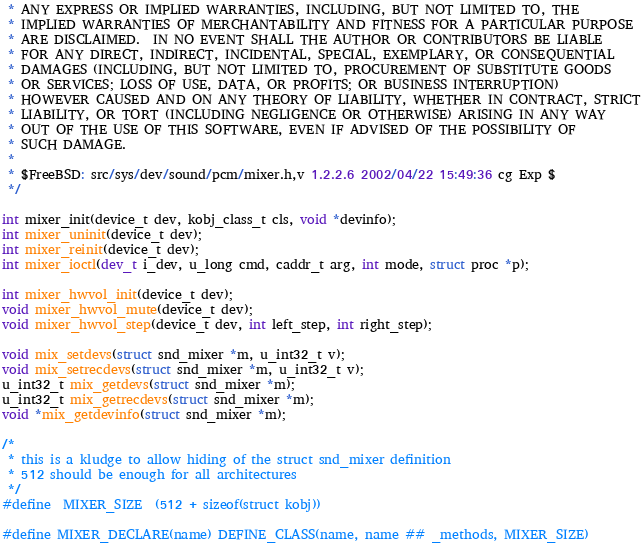<code> <loc_0><loc_0><loc_500><loc_500><_C_> * ANY EXPRESS OR IMPLIED WARRANTIES, INCLUDING, BUT NOT LIMITED TO, THE
 * IMPLIED WARRANTIES OF MERCHANTABILITY AND FITNESS FOR A PARTICULAR PURPOSE
 * ARE DISCLAIMED.  IN NO EVENT SHALL THE AUTHOR OR CONTRIBUTORS BE LIABLE
 * FOR ANY DIRECT, INDIRECT, INCIDENTAL, SPECIAL, EXEMPLARY, OR CONSEQUENTIAL
 * DAMAGES (INCLUDING, BUT NOT LIMITED TO, PROCUREMENT OF SUBSTITUTE GOODS
 * OR SERVICES; LOSS OF USE, DATA, OR PROFITS; OR BUSINESS INTERRUPTION)
 * HOWEVER CAUSED AND ON ANY THEORY OF LIABILITY, WHETHER IN CONTRACT, STRICT
 * LIABILITY, OR TORT (INCLUDING NEGLIGENCE OR OTHERWISE) ARISING IN ANY WAY
 * OUT OF THE USE OF THIS SOFTWARE, EVEN IF ADVISED OF THE POSSIBILITY OF
 * SUCH DAMAGE.
 *
 * $FreeBSD: src/sys/dev/sound/pcm/mixer.h,v 1.2.2.6 2002/04/22 15:49:36 cg Exp $
 */

int mixer_init(device_t dev, kobj_class_t cls, void *devinfo);
int mixer_uninit(device_t dev);
int mixer_reinit(device_t dev);
int mixer_ioctl(dev_t i_dev, u_long cmd, caddr_t arg, int mode, struct proc *p);

int mixer_hwvol_init(device_t dev);
void mixer_hwvol_mute(device_t dev);
void mixer_hwvol_step(device_t dev, int left_step, int right_step);

void mix_setdevs(struct snd_mixer *m, u_int32_t v);
void mix_setrecdevs(struct snd_mixer *m, u_int32_t v);
u_int32_t mix_getdevs(struct snd_mixer *m);
u_int32_t mix_getrecdevs(struct snd_mixer *m);
void *mix_getdevinfo(struct snd_mixer *m);

/*
 * this is a kludge to allow hiding of the struct snd_mixer definition
 * 512 should be enough for all architectures
 */
#define	MIXER_SIZE	(512 + sizeof(struct kobj))

#define MIXER_DECLARE(name) DEFINE_CLASS(name, name ## _methods, MIXER_SIZE)
</code> 